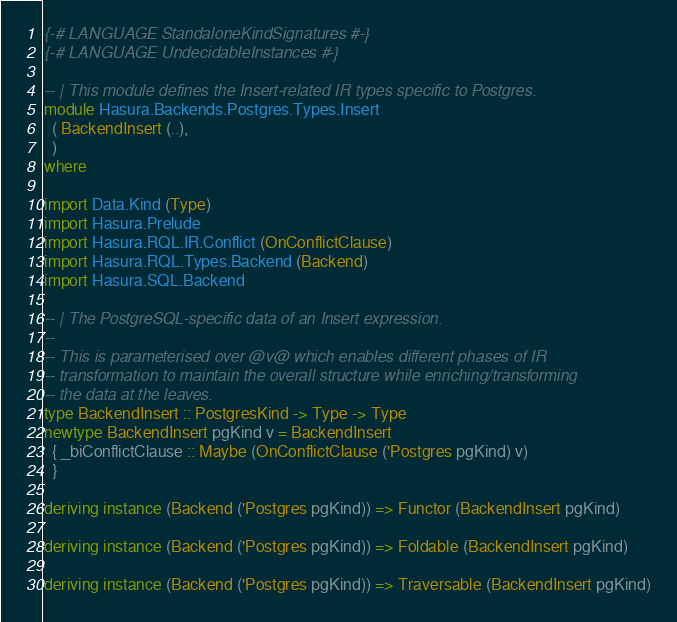<code> <loc_0><loc_0><loc_500><loc_500><_Haskell_>{-# LANGUAGE StandaloneKindSignatures #-}
{-# LANGUAGE UndecidableInstances #-}

-- | This module defines the Insert-related IR types specific to Postgres.
module Hasura.Backends.Postgres.Types.Insert
  ( BackendInsert (..),
  )
where

import Data.Kind (Type)
import Hasura.Prelude
import Hasura.RQL.IR.Conflict (OnConflictClause)
import Hasura.RQL.Types.Backend (Backend)
import Hasura.SQL.Backend

-- | The PostgreSQL-specific data of an Insert expression.
--
-- This is parameterised over @v@ which enables different phases of IR
-- transformation to maintain the overall structure while enriching/transforming
-- the data at the leaves.
type BackendInsert :: PostgresKind -> Type -> Type
newtype BackendInsert pgKind v = BackendInsert
  { _biConflictClause :: Maybe (OnConflictClause ('Postgres pgKind) v)
  }

deriving instance (Backend ('Postgres pgKind)) => Functor (BackendInsert pgKind)

deriving instance (Backend ('Postgres pgKind)) => Foldable (BackendInsert pgKind)

deriving instance (Backend ('Postgres pgKind)) => Traversable (BackendInsert pgKind)
</code> 